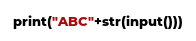<code> <loc_0><loc_0><loc_500><loc_500><_Python_>print("ABC"+str(input()))</code> 